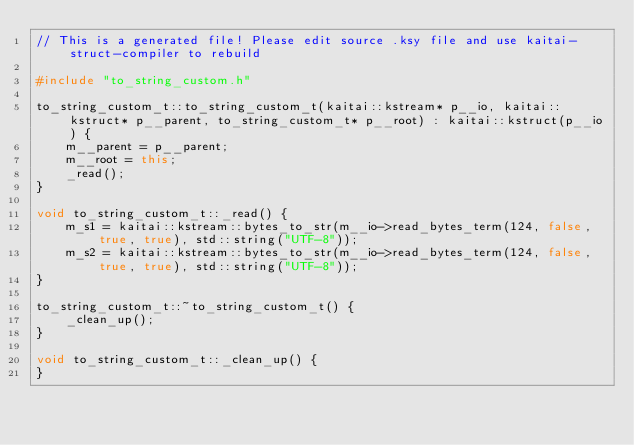Convert code to text. <code><loc_0><loc_0><loc_500><loc_500><_C++_>// This is a generated file! Please edit source .ksy file and use kaitai-struct-compiler to rebuild

#include "to_string_custom.h"

to_string_custom_t::to_string_custom_t(kaitai::kstream* p__io, kaitai::kstruct* p__parent, to_string_custom_t* p__root) : kaitai::kstruct(p__io) {
    m__parent = p__parent;
    m__root = this;
    _read();
}

void to_string_custom_t::_read() {
    m_s1 = kaitai::kstream::bytes_to_str(m__io->read_bytes_term(124, false, true, true), std::string("UTF-8"));
    m_s2 = kaitai::kstream::bytes_to_str(m__io->read_bytes_term(124, false, true, true), std::string("UTF-8"));
}

to_string_custom_t::~to_string_custom_t() {
    _clean_up();
}

void to_string_custom_t::_clean_up() {
}
</code> 